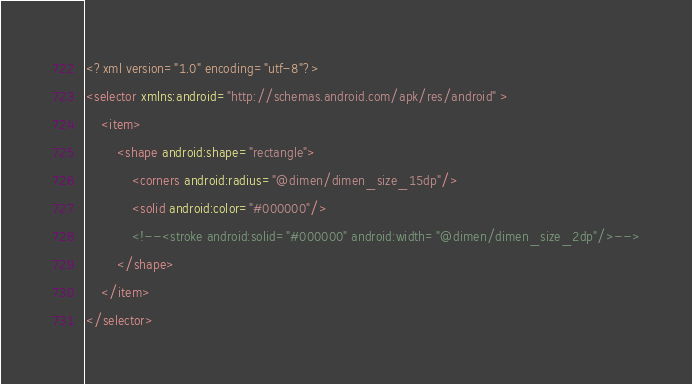Convert code to text. <code><loc_0><loc_0><loc_500><loc_500><_XML_><?xml version="1.0" encoding="utf-8"?>
<selector xmlns:android="http://schemas.android.com/apk/res/android" >
    <item>
        <shape android:shape="rectangle">
            <corners android:radius="@dimen/dimen_size_15dp"/>
            <solid android:color="#000000"/>
            <!--<stroke android:solid="#000000" android:width="@dimen/dimen_size_2dp"/>-->
        </shape>
    </item>
</selector></code> 